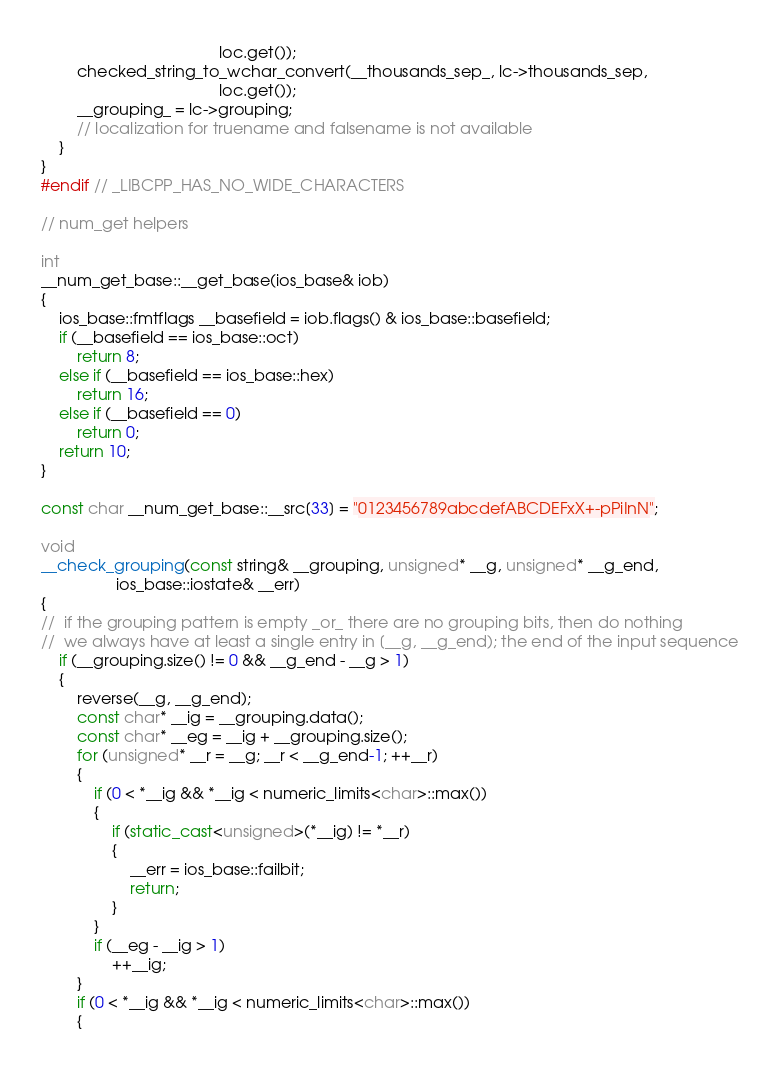Convert code to text. <code><loc_0><loc_0><loc_500><loc_500><_C++_>                                        loc.get());
        checked_string_to_wchar_convert(__thousands_sep_, lc->thousands_sep,
                                        loc.get());
        __grouping_ = lc->grouping;
        // localization for truename and falsename is not available
    }
}
#endif // _LIBCPP_HAS_NO_WIDE_CHARACTERS

// num_get helpers

int
__num_get_base::__get_base(ios_base& iob)
{
    ios_base::fmtflags __basefield = iob.flags() & ios_base::basefield;
    if (__basefield == ios_base::oct)
        return 8;
    else if (__basefield == ios_base::hex)
        return 16;
    else if (__basefield == 0)
        return 0;
    return 10;
}

const char __num_get_base::__src[33] = "0123456789abcdefABCDEFxX+-pPiInN";

void
__check_grouping(const string& __grouping, unsigned* __g, unsigned* __g_end,
                 ios_base::iostate& __err)
{
//  if the grouping pattern is empty _or_ there are no grouping bits, then do nothing
//  we always have at least a single entry in [__g, __g_end); the end of the input sequence
	if (__grouping.size() != 0 && __g_end - __g > 1)
    {
        reverse(__g, __g_end);
        const char* __ig = __grouping.data();
        const char* __eg = __ig + __grouping.size();
        for (unsigned* __r = __g; __r < __g_end-1; ++__r)
        {
            if (0 < *__ig && *__ig < numeric_limits<char>::max())
            {
                if (static_cast<unsigned>(*__ig) != *__r)
                {
                    __err = ios_base::failbit;
                    return;
                }
            }
            if (__eg - __ig > 1)
                ++__ig;
        }
        if (0 < *__ig && *__ig < numeric_limits<char>::max())
        {</code> 